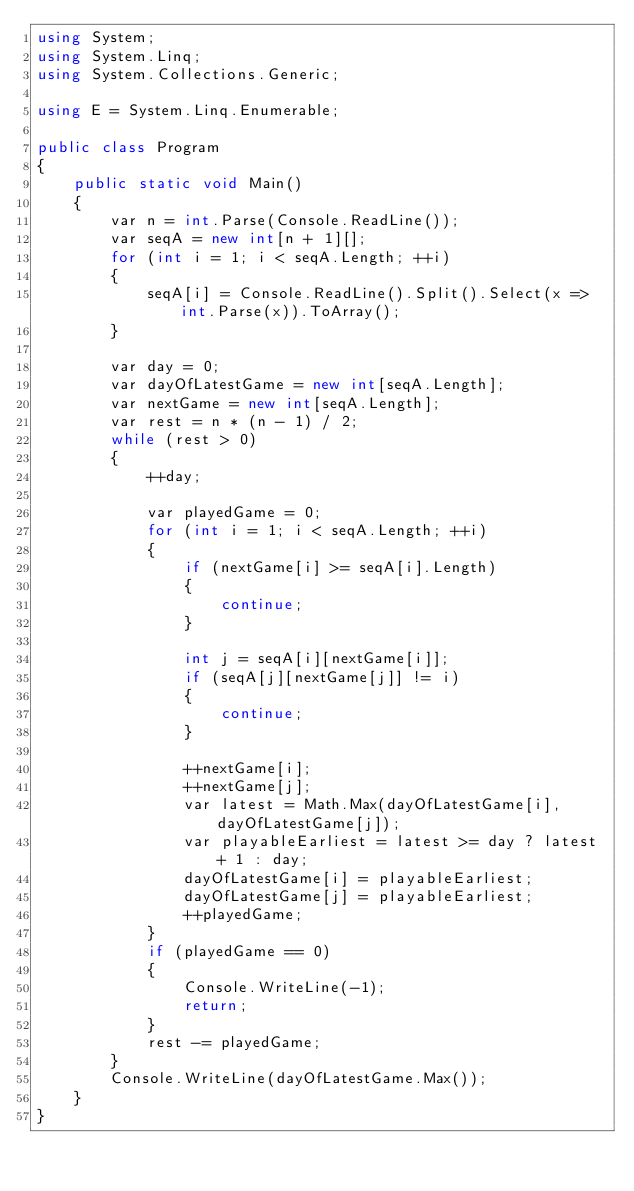Convert code to text. <code><loc_0><loc_0><loc_500><loc_500><_C#_>using System;
using System.Linq;
using System.Collections.Generic;

using E = System.Linq.Enumerable;

public class Program
{
    public static void Main()
    {
        var n = int.Parse(Console.ReadLine());
        var seqA = new int[n + 1][];
        for (int i = 1; i < seqA.Length; ++i)
        {
            seqA[i] = Console.ReadLine().Split().Select(x => int.Parse(x)).ToArray();
        }

        var day = 0;
        var dayOfLatestGame = new int[seqA.Length];
        var nextGame = new int[seqA.Length];
        var rest = n * (n - 1) / 2;
        while (rest > 0)
        {
            ++day;

            var playedGame = 0;
            for (int i = 1; i < seqA.Length; ++i)
            {
                if (nextGame[i] >= seqA[i].Length)
                {
                    continue;
                }

                int j = seqA[i][nextGame[i]];
                if (seqA[j][nextGame[j]] != i)
                {
                    continue;
                }

                ++nextGame[i];
                ++nextGame[j];
                var latest = Math.Max(dayOfLatestGame[i], dayOfLatestGame[j]);
                var playableEarliest = latest >= day ? latest + 1 : day;
                dayOfLatestGame[i] = playableEarliest;
                dayOfLatestGame[j] = playableEarliest;
                ++playedGame;
            }
            if (playedGame == 0)
            {
                Console.WriteLine(-1);
                return;
            }
            rest -= playedGame;
        }
        Console.WriteLine(dayOfLatestGame.Max());
    }
}
</code> 